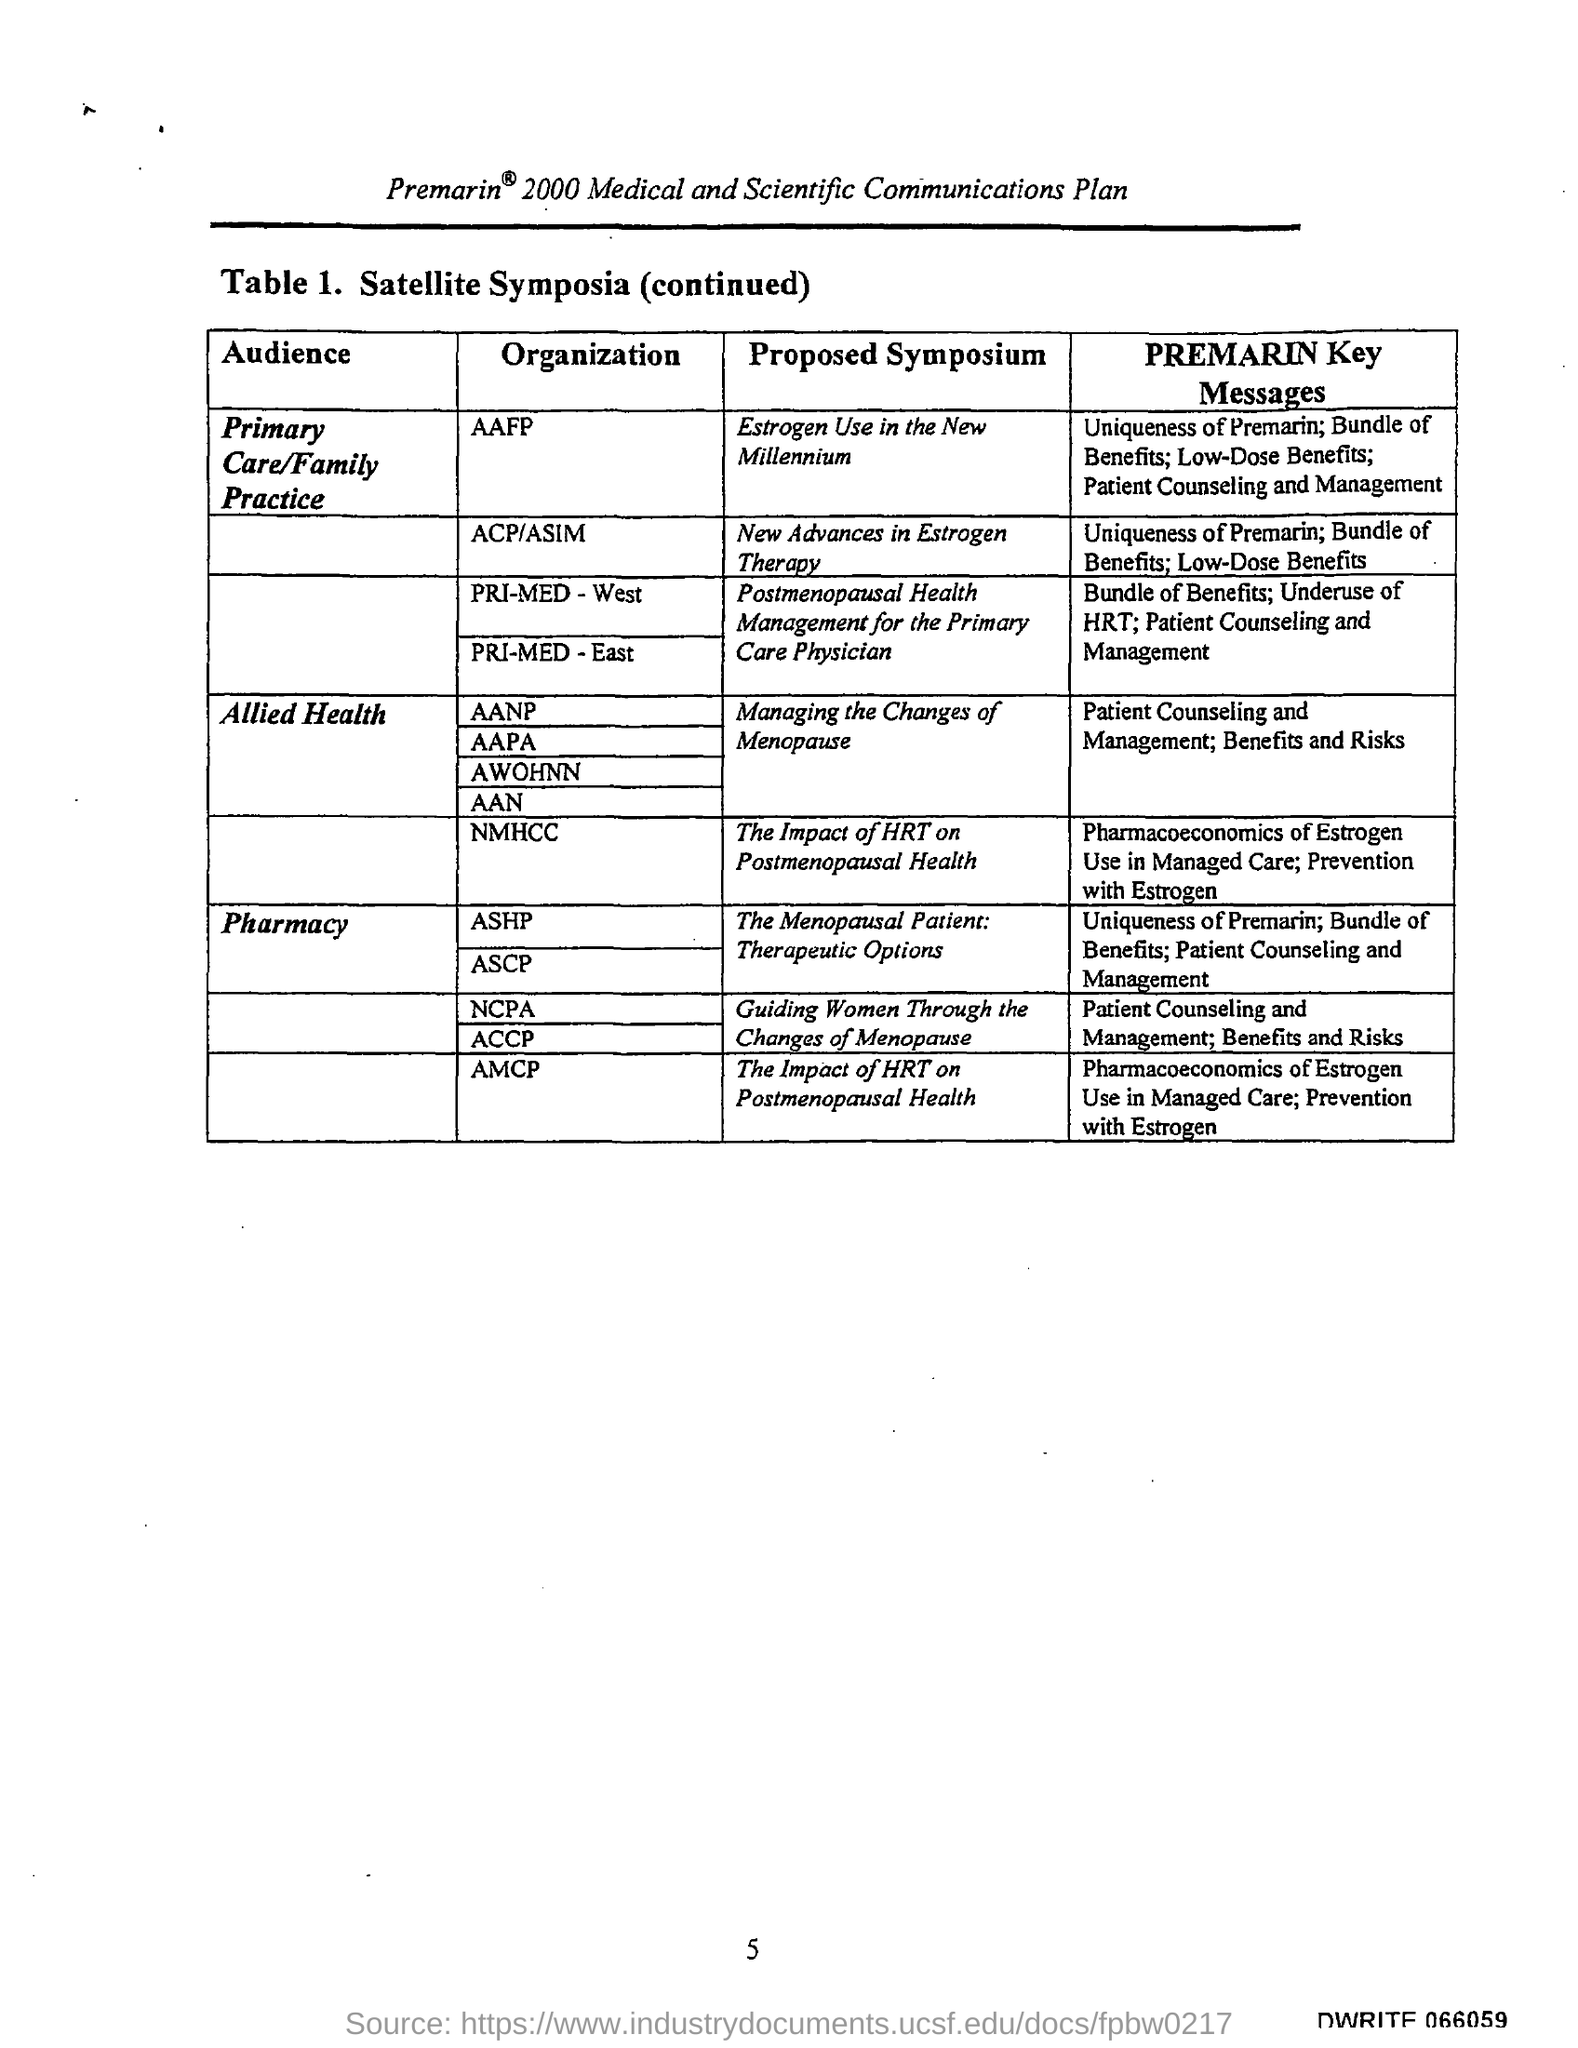Mention a couple of crucial points in this snapshot. The title of Table 1 is "Satellite Symposia (continued).". The PREMARIN key messages for the American Association of Nurse Practitioners (AANP) include patient counseling and management, as well as an understanding of the benefits and risks associated with the medication. The document contains page number 5. 